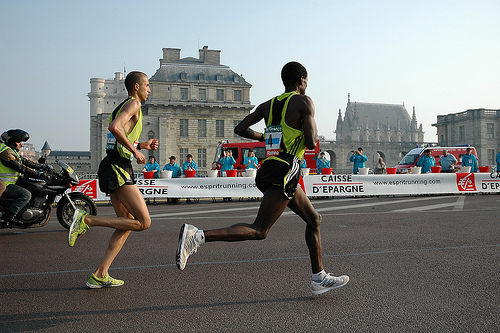What time of day does the lighting suggest the image was taken? The lighting in the image appears soft and diffused, lacking harsh shadows, which might indicate it was taken in the early morning or later in the afternoon. The visibility is clear, and the overall ambiance is calm, suitable for such an endurance event. Does the image convey a sense of motion or stillness? There is a distinct sense of motion due to the runners' postures and the stride of their legs. The crisp focus on the athletes, contrasted against the slightly blurred background, accentuates the movement and the speed at which the runners are moving. 